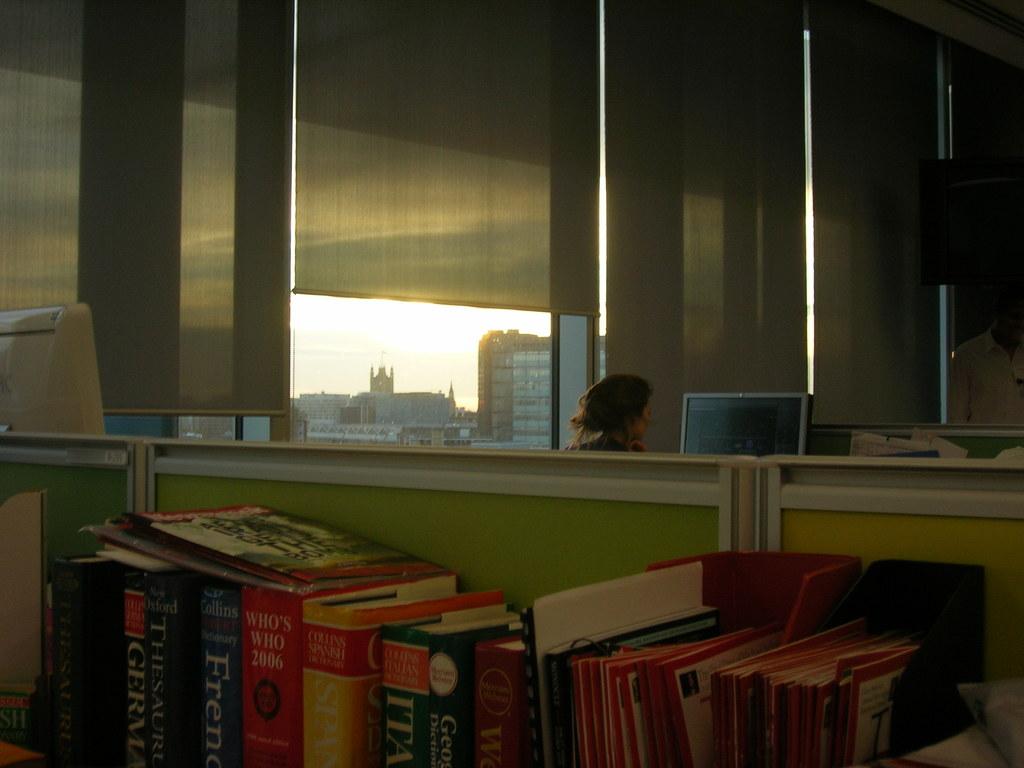What year is the who's who book?
Your response must be concise. 2006. What is the top word on the french book?
Give a very brief answer. Collins. 